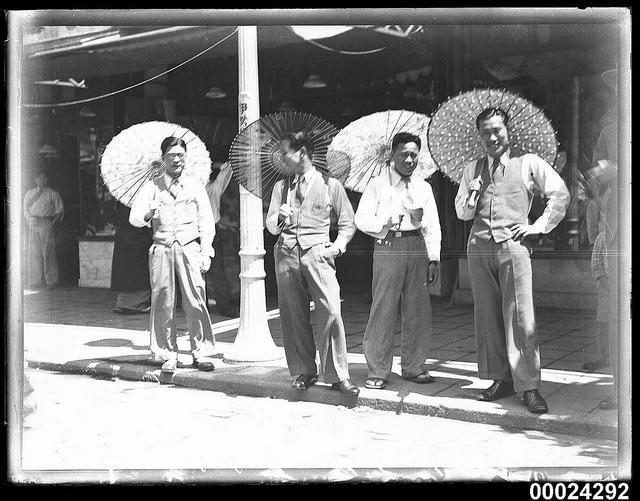How many parasols are in this photo?
Give a very brief answer. 4. How many people are in the picture?
Give a very brief answer. 5. How many umbrellas are in the photo?
Give a very brief answer. 4. 